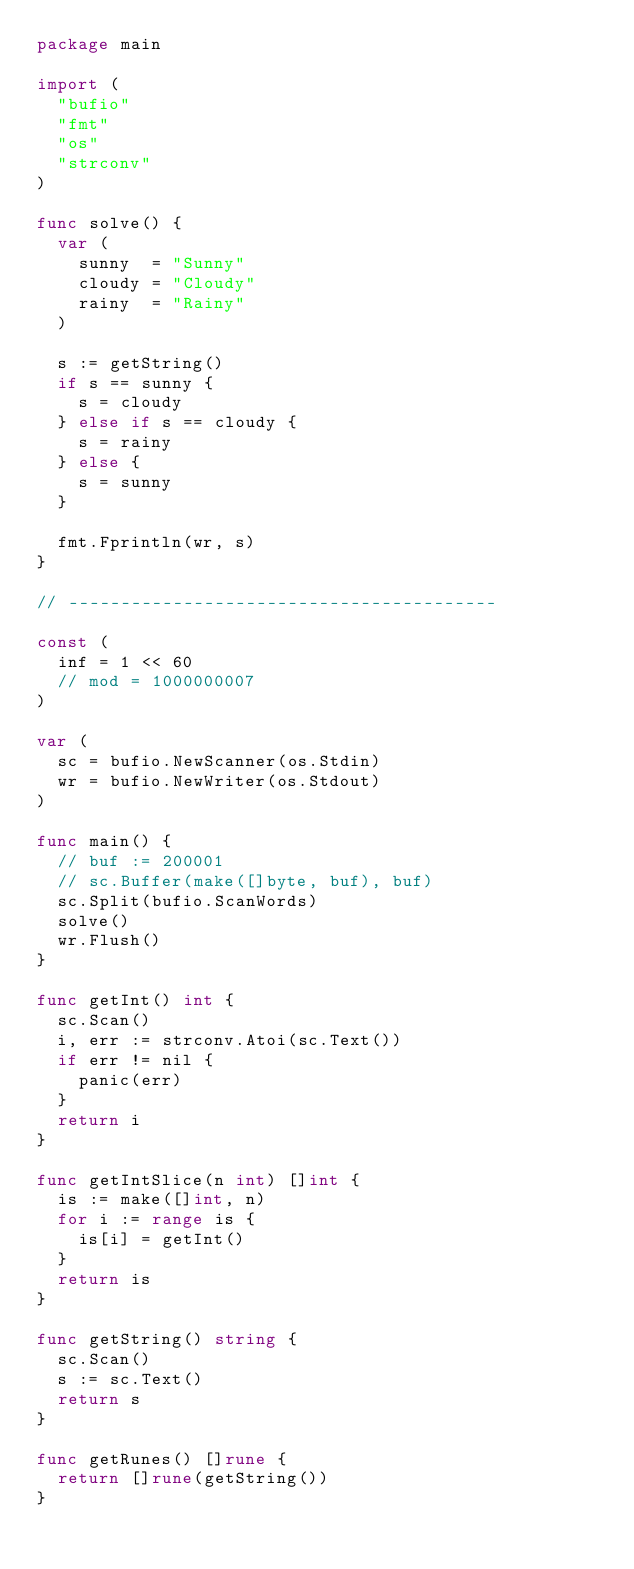Convert code to text. <code><loc_0><loc_0><loc_500><loc_500><_Go_>package main

import (
	"bufio"
	"fmt"
	"os"
	"strconv"
)

func solve() {
	var (
		sunny  = "Sunny"
		cloudy = "Cloudy"
		rainy  = "Rainy"
	)

	s := getString()
	if s == sunny {
		s = cloudy
	} else if s == cloudy {
		s = rainy
	} else {
		s = sunny
	}

	fmt.Fprintln(wr, s)
}

// -----------------------------------------

const (
	inf = 1 << 60
	// mod = 1000000007
)

var (
	sc = bufio.NewScanner(os.Stdin)
	wr = bufio.NewWriter(os.Stdout)
)

func main() {
	// buf := 200001
	// sc.Buffer(make([]byte, buf), buf)
	sc.Split(bufio.ScanWords)
	solve()
	wr.Flush()
}

func getInt() int {
	sc.Scan()
	i, err := strconv.Atoi(sc.Text())
	if err != nil {
		panic(err)
	}
	return i
}

func getIntSlice(n int) []int {
	is := make([]int, n)
	for i := range is {
		is[i] = getInt()
	}
	return is
}

func getString() string {
	sc.Scan()
	s := sc.Text()
	return s
}

func getRunes() []rune {
	return []rune(getString())
}
</code> 